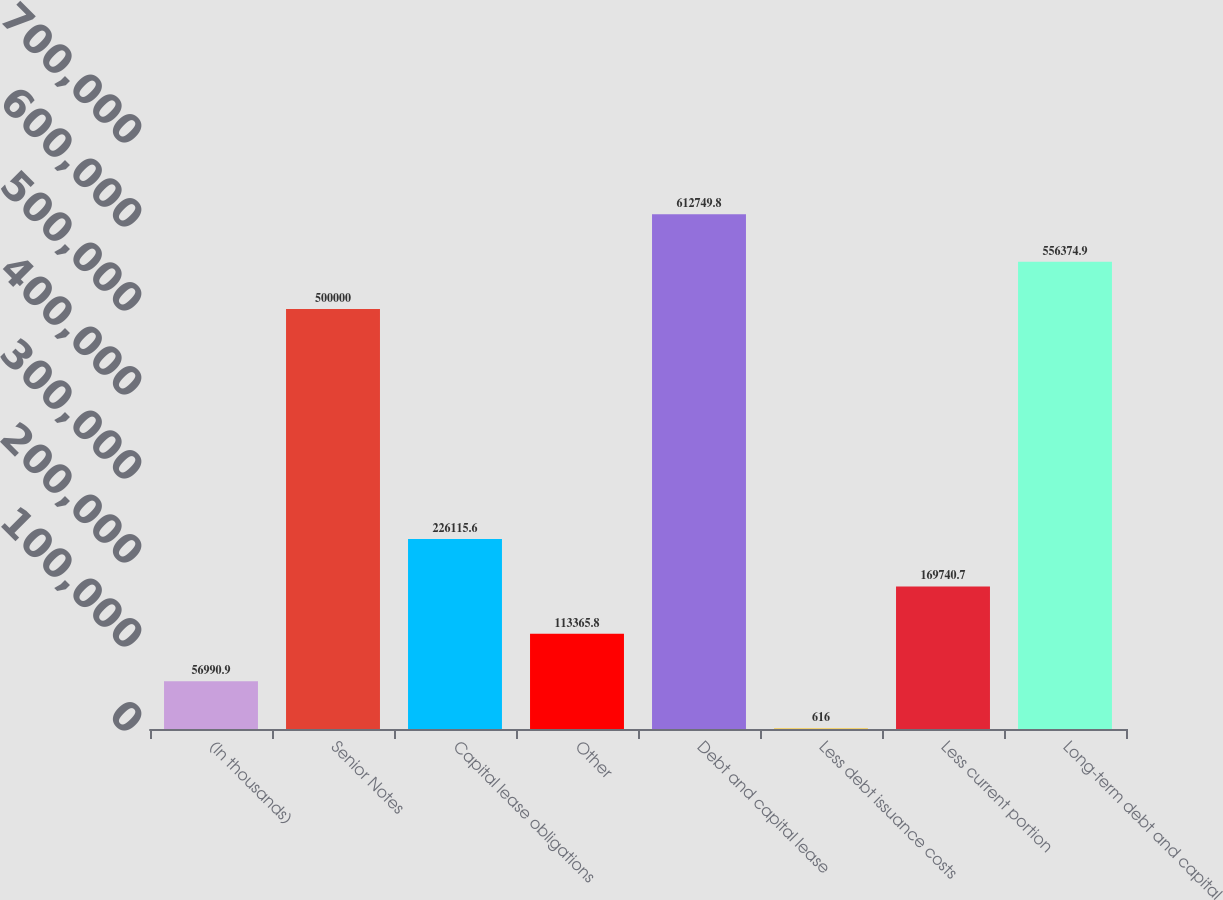Convert chart. <chart><loc_0><loc_0><loc_500><loc_500><bar_chart><fcel>(In thousands)<fcel>Senior Notes<fcel>Capital lease obligations<fcel>Other<fcel>Debt and capital lease<fcel>Less debt issuance costs<fcel>Less current portion<fcel>Long-term debt and capital<nl><fcel>56990.9<fcel>500000<fcel>226116<fcel>113366<fcel>612750<fcel>616<fcel>169741<fcel>556375<nl></chart> 